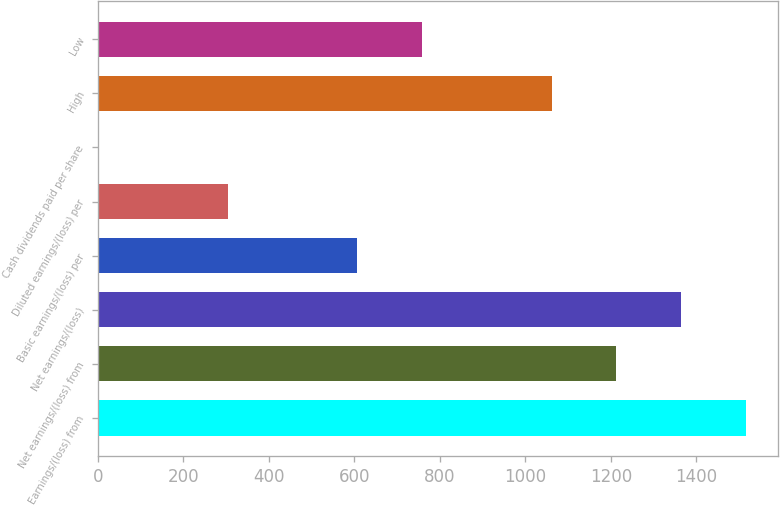Convert chart to OTSL. <chart><loc_0><loc_0><loc_500><loc_500><bar_chart><fcel>Earnings/(loss) from<fcel>Net earnings/(loss) from<fcel>Net earnings/(loss)<fcel>Basic earnings/(loss) per<fcel>Diluted earnings/(loss) per<fcel>Cash dividends paid per share<fcel>High<fcel>Low<nl><fcel>1516.03<fcel>1212.89<fcel>1364.46<fcel>606.62<fcel>303.49<fcel>0.35<fcel>1061.33<fcel>758.19<nl></chart> 